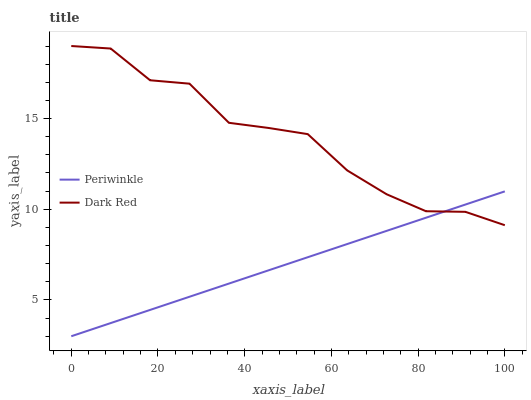Does Periwinkle have the minimum area under the curve?
Answer yes or no. Yes. Does Dark Red have the maximum area under the curve?
Answer yes or no. Yes. Does Periwinkle have the maximum area under the curve?
Answer yes or no. No. Is Periwinkle the smoothest?
Answer yes or no. Yes. Is Dark Red the roughest?
Answer yes or no. Yes. Is Periwinkle the roughest?
Answer yes or no. No. Does Periwinkle have the lowest value?
Answer yes or no. Yes. Does Dark Red have the highest value?
Answer yes or no. Yes. Does Periwinkle have the highest value?
Answer yes or no. No. Does Periwinkle intersect Dark Red?
Answer yes or no. Yes. Is Periwinkle less than Dark Red?
Answer yes or no. No. Is Periwinkle greater than Dark Red?
Answer yes or no. No. 